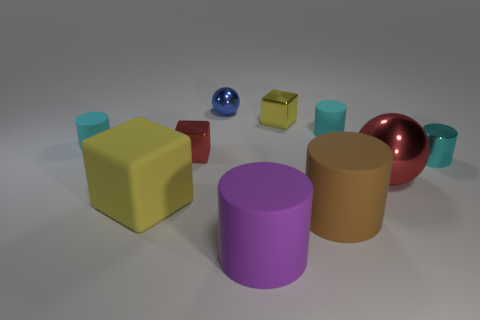Subtract all red blocks. How many blocks are left? 2 Subtract all brown cylinders. How many cylinders are left? 4 Subtract 1 cubes. How many cubes are left? 2 Subtract all purple spheres. How many green cubes are left? 0 Add 8 tiny cyan rubber cylinders. How many tiny cyan rubber cylinders exist? 10 Subtract 0 gray cubes. How many objects are left? 10 Subtract all blocks. How many objects are left? 7 Subtract all gray spheres. Subtract all brown blocks. How many spheres are left? 2 Subtract all tiny cyan things. Subtract all purple objects. How many objects are left? 6 Add 6 cyan cylinders. How many cyan cylinders are left? 9 